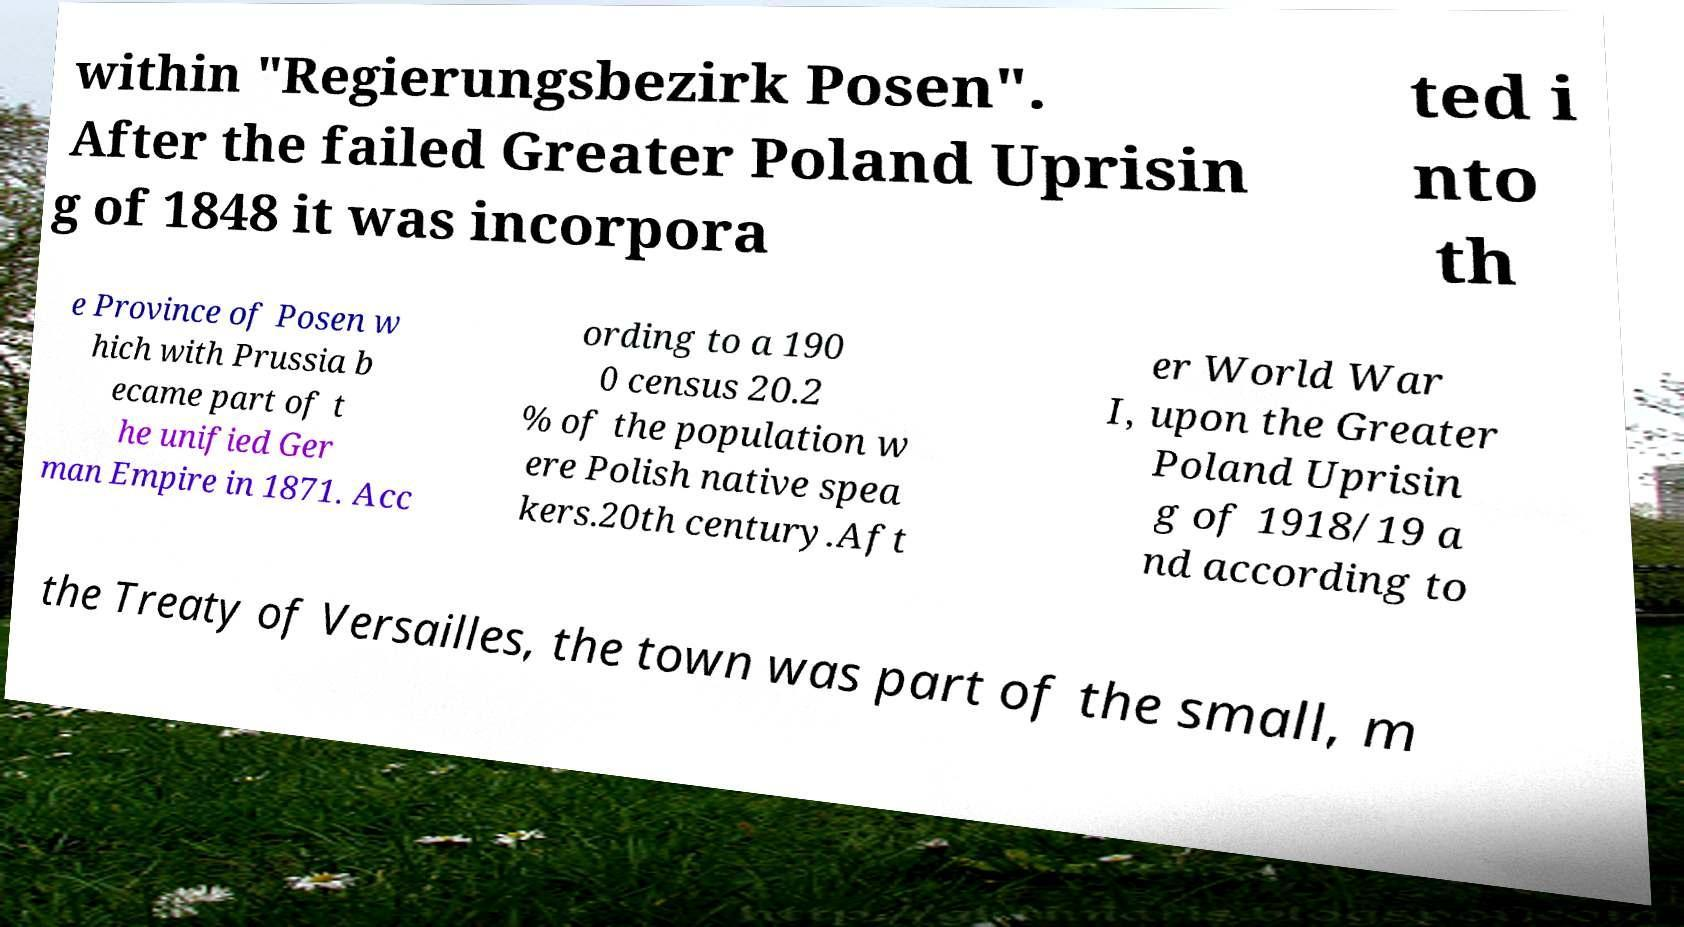Can you read and provide the text displayed in the image?This photo seems to have some interesting text. Can you extract and type it out for me? within "Regierungsbezirk Posen". After the failed Greater Poland Uprisin g of 1848 it was incorpora ted i nto th e Province of Posen w hich with Prussia b ecame part of t he unified Ger man Empire in 1871. Acc ording to a 190 0 census 20.2 % of the population w ere Polish native spea kers.20th century.Aft er World War I, upon the Greater Poland Uprisin g of 1918/19 a nd according to the Treaty of Versailles, the town was part of the small, m 